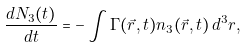<formula> <loc_0><loc_0><loc_500><loc_500>\frac { d N _ { 3 } ( t ) } { d t } = - \int { \Gamma ( \vec { r } , t ) n _ { 3 } ( \vec { r } , t ) \, d ^ { 3 } r } ,</formula> 